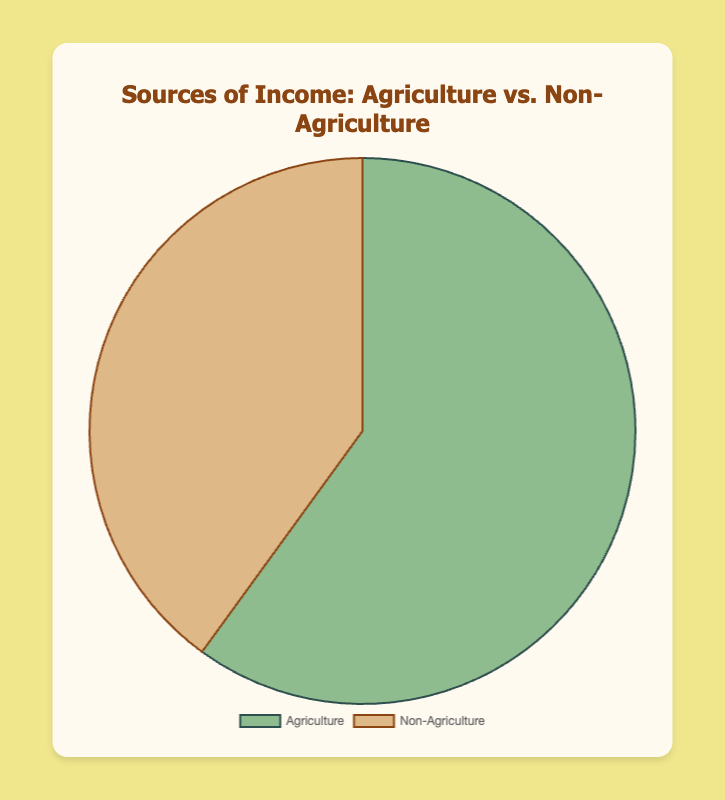What's the largest source of income? By looking at the pie chart, the largest source of income is visually represented by the biggest segment. Since 60% is allocated for Agriculture, it is the largest source.
Answer: Agriculture What's the difference between the percentages of Agriculture and Non-Agriculture income? From the pie chart, Agriculture occupies 60% and Non-Agriculture occupies 40%. The difference is calculated as 60% - 40%.
Answer: 20% Which income source category is shown in green? The visual attribute you need to focus on is the color. The green segment represents Agriculture as per the data definition.
Answer: Agriculture What is the combined percentage of income from Crop Farming and Livestock? Crop Farming and Livestock fall under Agriculture and contribute 35% and 25% respectively. The combined percentage is 35% + 25%.
Answer: 60% Which Non-Agriculture source has an equal percentage as Small Business? In the pie chart, Small Business is part of Non-Agriculture making up 20%. The same percentage is seen in Remittances.
Answer: Remittances What category represents 40% of the total income? Observing the pie chart, the total percentage for Non-Agriculture income is 40%, which is represented by the second-largest segment.
Answer: Non-Agriculture How many agricultural sources are there and what is their total contribution percentage? Examine the segments allocated to Agriculture, which consist of Crop Farming and Livestock with a combined share of 35% + 25%. So, there are 2 sources totaling 60%.
Answer: 2 sources, 60% What is the percentage of income from Non-Agriculture sources individually? Non-Agriculture income is divided between Remittances and Small Business, each contributing 20%. The figures can be directly read off the pie chart.
Answer: 20% each Which category is represented with a brown color? The visual attribute you need to observe is the brown color section of the pie chart. It represents the Non-Agriculture category.
Answer: Non-Agriculture 